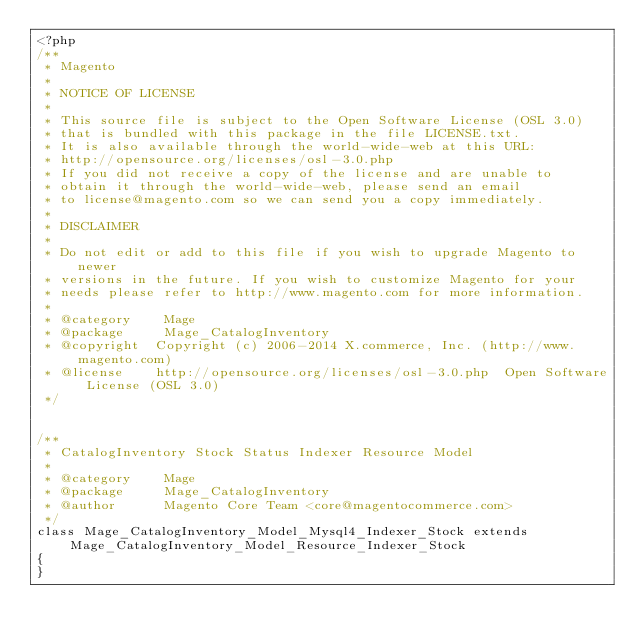<code> <loc_0><loc_0><loc_500><loc_500><_PHP_><?php
/**
 * Magento
 *
 * NOTICE OF LICENSE
 *
 * This source file is subject to the Open Software License (OSL 3.0)
 * that is bundled with this package in the file LICENSE.txt.
 * It is also available through the world-wide-web at this URL:
 * http://opensource.org/licenses/osl-3.0.php
 * If you did not receive a copy of the license and are unable to
 * obtain it through the world-wide-web, please send an email
 * to license@magento.com so we can send you a copy immediately.
 *
 * DISCLAIMER
 *
 * Do not edit or add to this file if you wish to upgrade Magento to newer
 * versions in the future. If you wish to customize Magento for your
 * needs please refer to http://www.magento.com for more information.
 *
 * @category    Mage
 * @package     Mage_CatalogInventory
 * @copyright  Copyright (c) 2006-2014 X.commerce, Inc. (http://www.magento.com)
 * @license    http://opensource.org/licenses/osl-3.0.php  Open Software License (OSL 3.0)
 */


/**
 * CatalogInventory Stock Status Indexer Resource Model
 *
 * @category    Mage
 * @package     Mage_CatalogInventory
 * @author      Magento Core Team <core@magentocommerce.com>
 */
class Mage_CatalogInventory_Model_Mysql4_Indexer_Stock extends Mage_CatalogInventory_Model_Resource_Indexer_Stock
{
}
</code> 